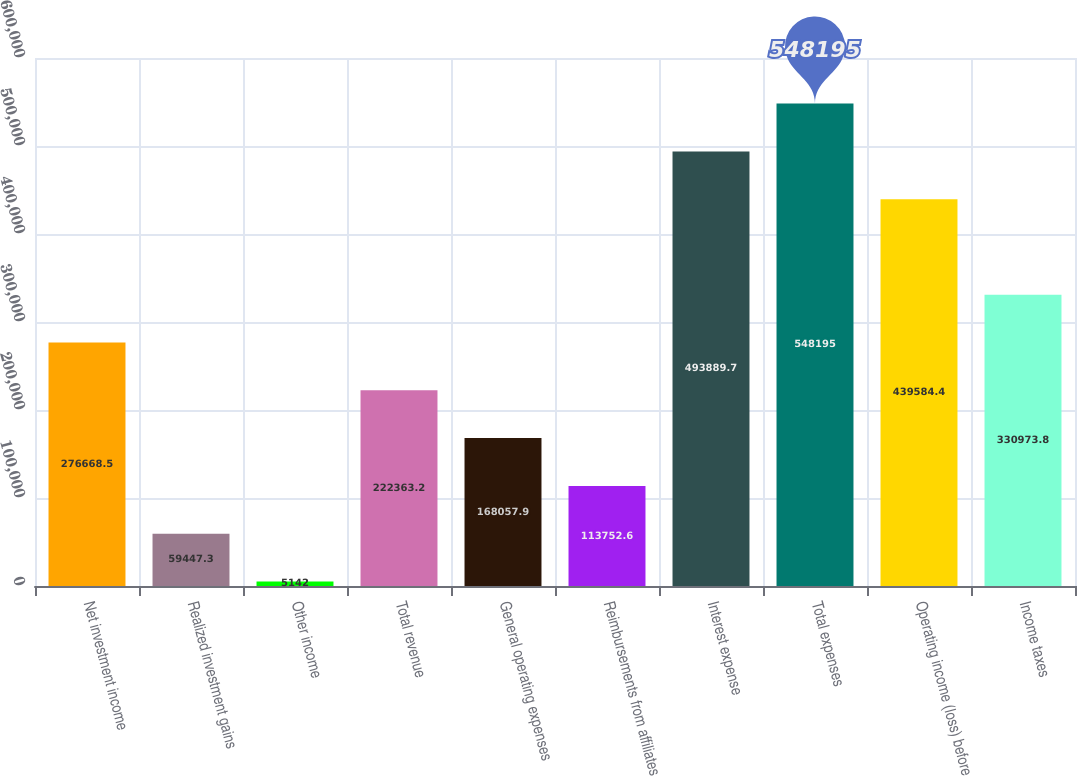Convert chart. <chart><loc_0><loc_0><loc_500><loc_500><bar_chart><fcel>Net investment income<fcel>Realized investment gains<fcel>Other income<fcel>Total revenue<fcel>General operating expenses<fcel>Reimbursements from affiliates<fcel>Interest expense<fcel>Total expenses<fcel>Operating income (loss) before<fcel>Income taxes<nl><fcel>276668<fcel>59447.3<fcel>5142<fcel>222363<fcel>168058<fcel>113753<fcel>493890<fcel>548195<fcel>439584<fcel>330974<nl></chart> 